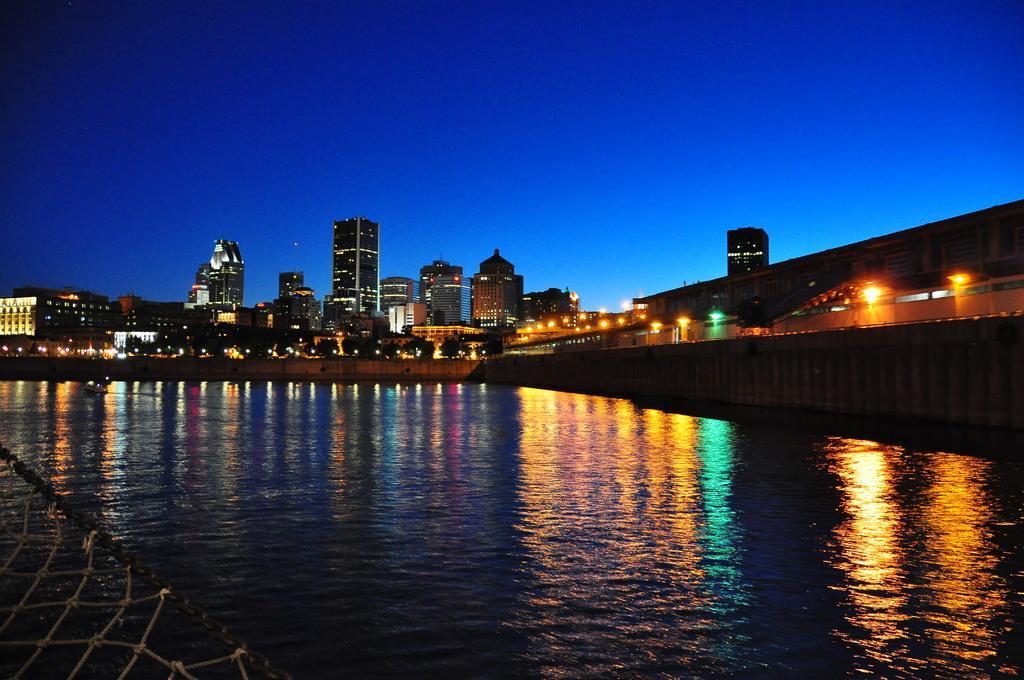Can you describe this image briefly? In this image I can see water, number of buildings, lights, the sky and I can see this image is little bit in dark. 